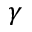<formula> <loc_0><loc_0><loc_500><loc_500>\gamma</formula> 